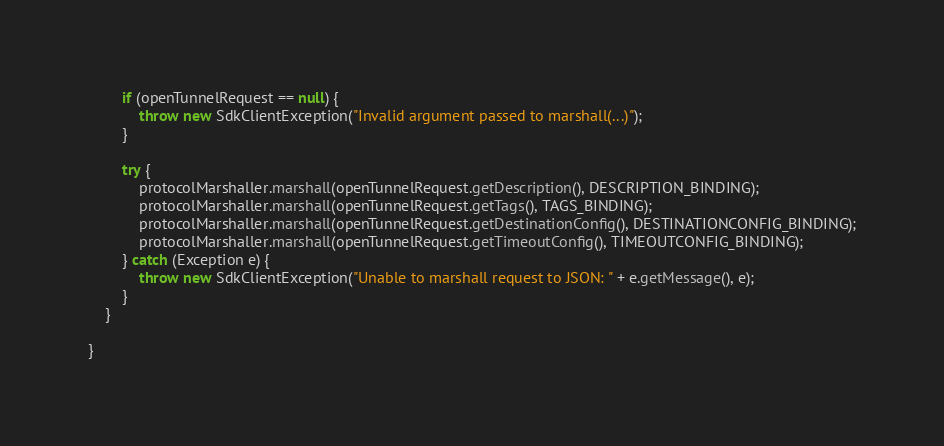<code> <loc_0><loc_0><loc_500><loc_500><_Java_>
        if (openTunnelRequest == null) {
            throw new SdkClientException("Invalid argument passed to marshall(...)");
        }

        try {
            protocolMarshaller.marshall(openTunnelRequest.getDescription(), DESCRIPTION_BINDING);
            protocolMarshaller.marshall(openTunnelRequest.getTags(), TAGS_BINDING);
            protocolMarshaller.marshall(openTunnelRequest.getDestinationConfig(), DESTINATIONCONFIG_BINDING);
            protocolMarshaller.marshall(openTunnelRequest.getTimeoutConfig(), TIMEOUTCONFIG_BINDING);
        } catch (Exception e) {
            throw new SdkClientException("Unable to marshall request to JSON: " + e.getMessage(), e);
        }
    }

}
</code> 